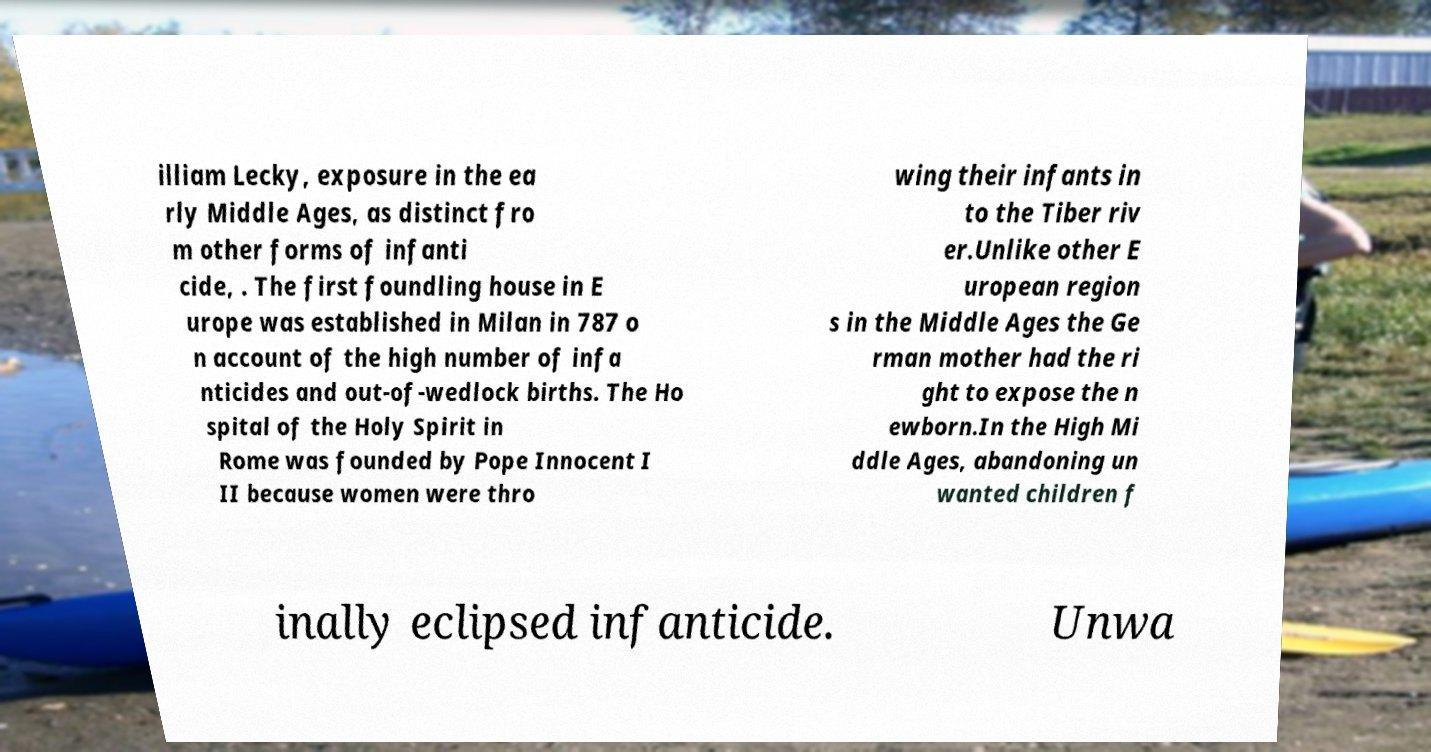There's text embedded in this image that I need extracted. Can you transcribe it verbatim? illiam Lecky, exposure in the ea rly Middle Ages, as distinct fro m other forms of infanti cide, . The first foundling house in E urope was established in Milan in 787 o n account of the high number of infa nticides and out-of-wedlock births. The Ho spital of the Holy Spirit in Rome was founded by Pope Innocent I II because women were thro wing their infants in to the Tiber riv er.Unlike other E uropean region s in the Middle Ages the Ge rman mother had the ri ght to expose the n ewborn.In the High Mi ddle Ages, abandoning un wanted children f inally eclipsed infanticide. Unwa 